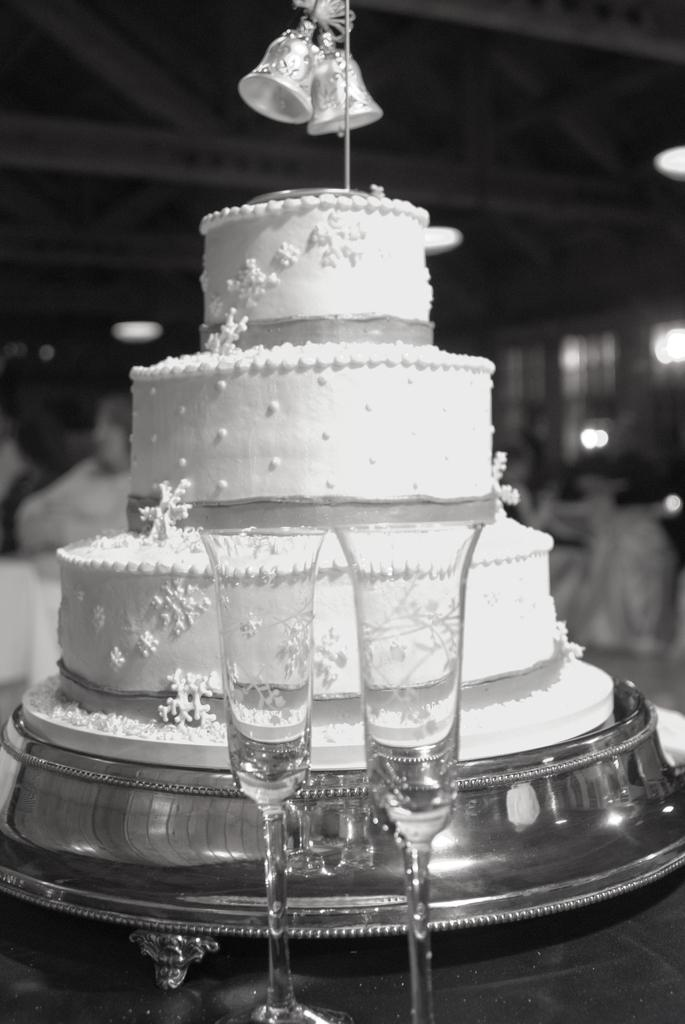What is placed on the table in the image? There is a cake placed on the table. What can be seen in front of the cake? There are two wine glasses in front of the cake. Can you describe the background of the image? The background of the image is blurred. What is the color scheme of the image? The image is black and white. How many geese are crossing the road in the image? There are no geese or roads present in the image; it features a cake and wine glasses on a table. What type of meat is being served with the cake in the image? There is no meat present in the image; it only features a cake and wine glasses. 